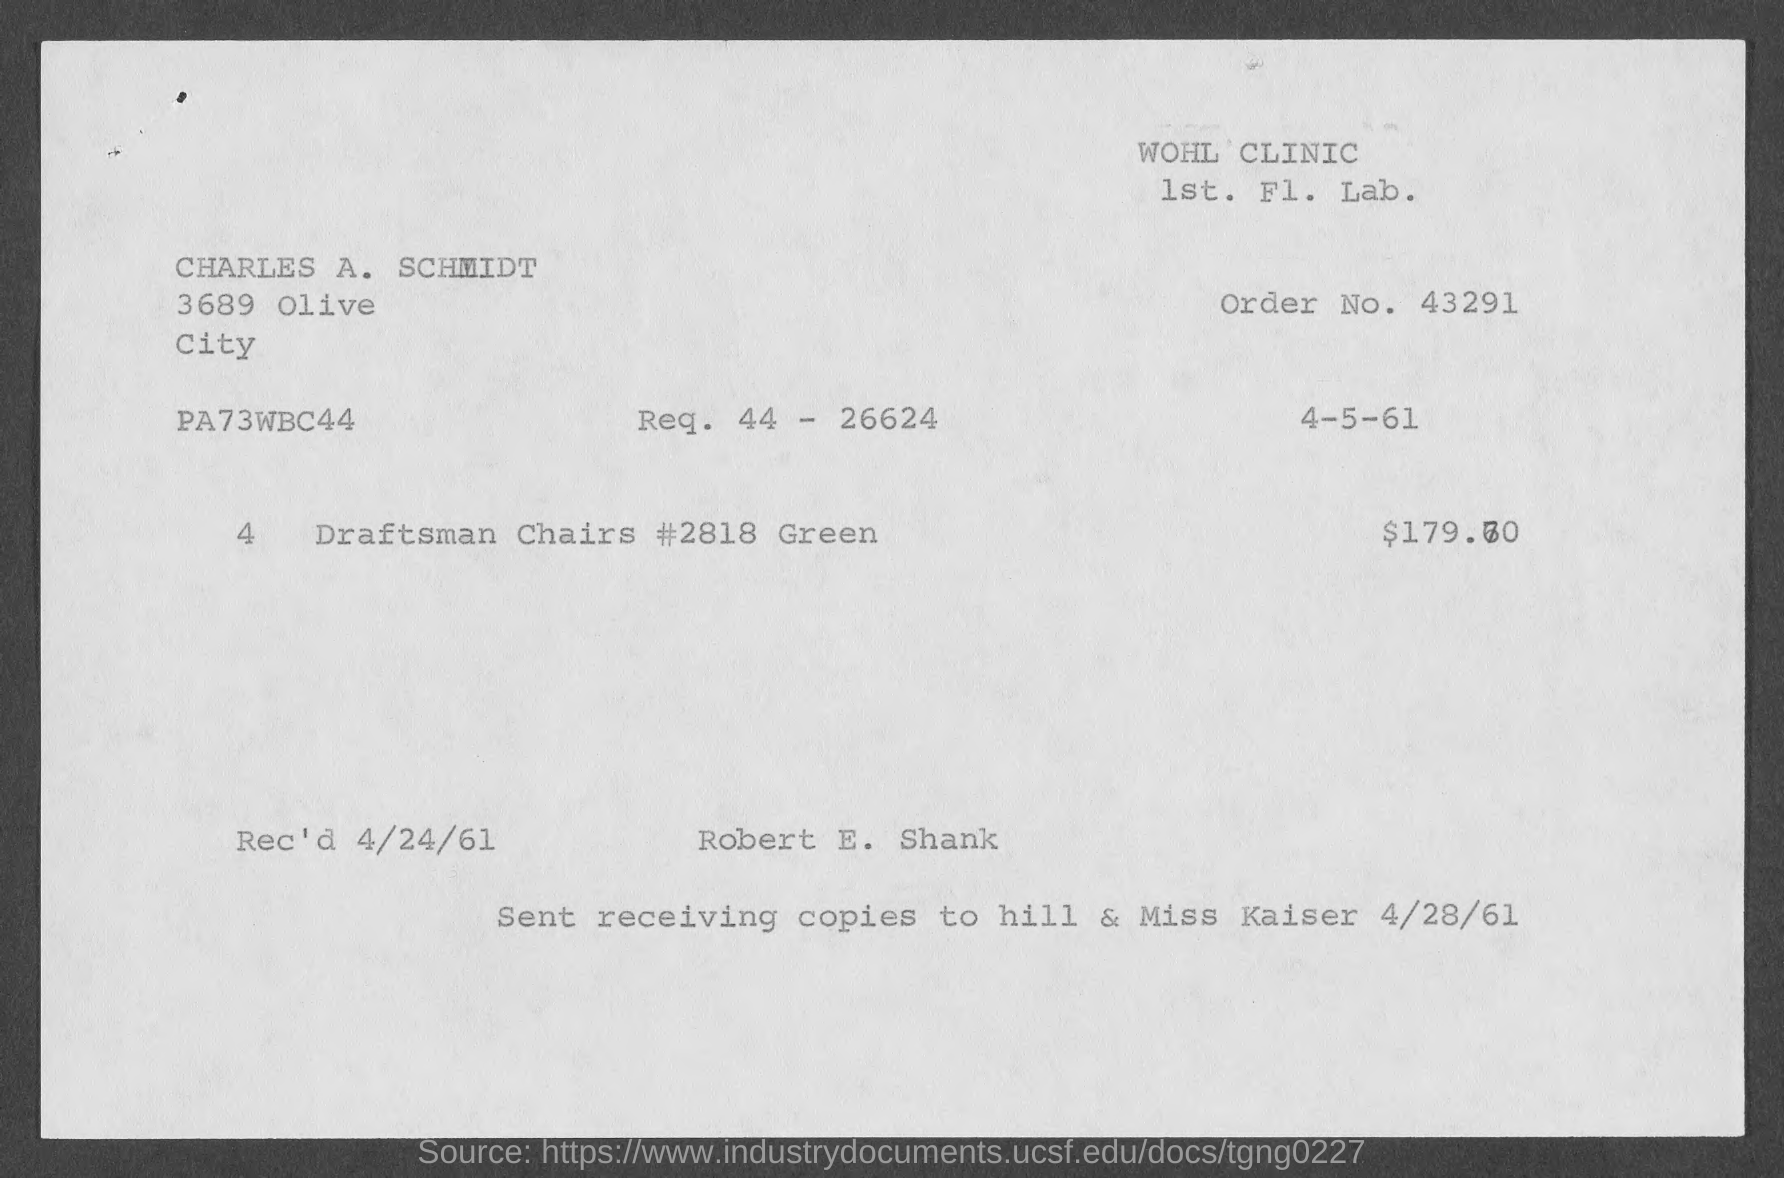What is the order no.?
Provide a short and direct response. 43291. What is the Req. ?
Provide a short and direct response. 44 - 26624. To whom should receiving copies be sent?
Ensure brevity in your answer.  Hill & miss kaiser. When was the document received?
Your answer should be very brief. 4/24/61. 